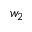Convert formula to latex. <formula><loc_0><loc_0><loc_500><loc_500>w _ { 2 }</formula> 